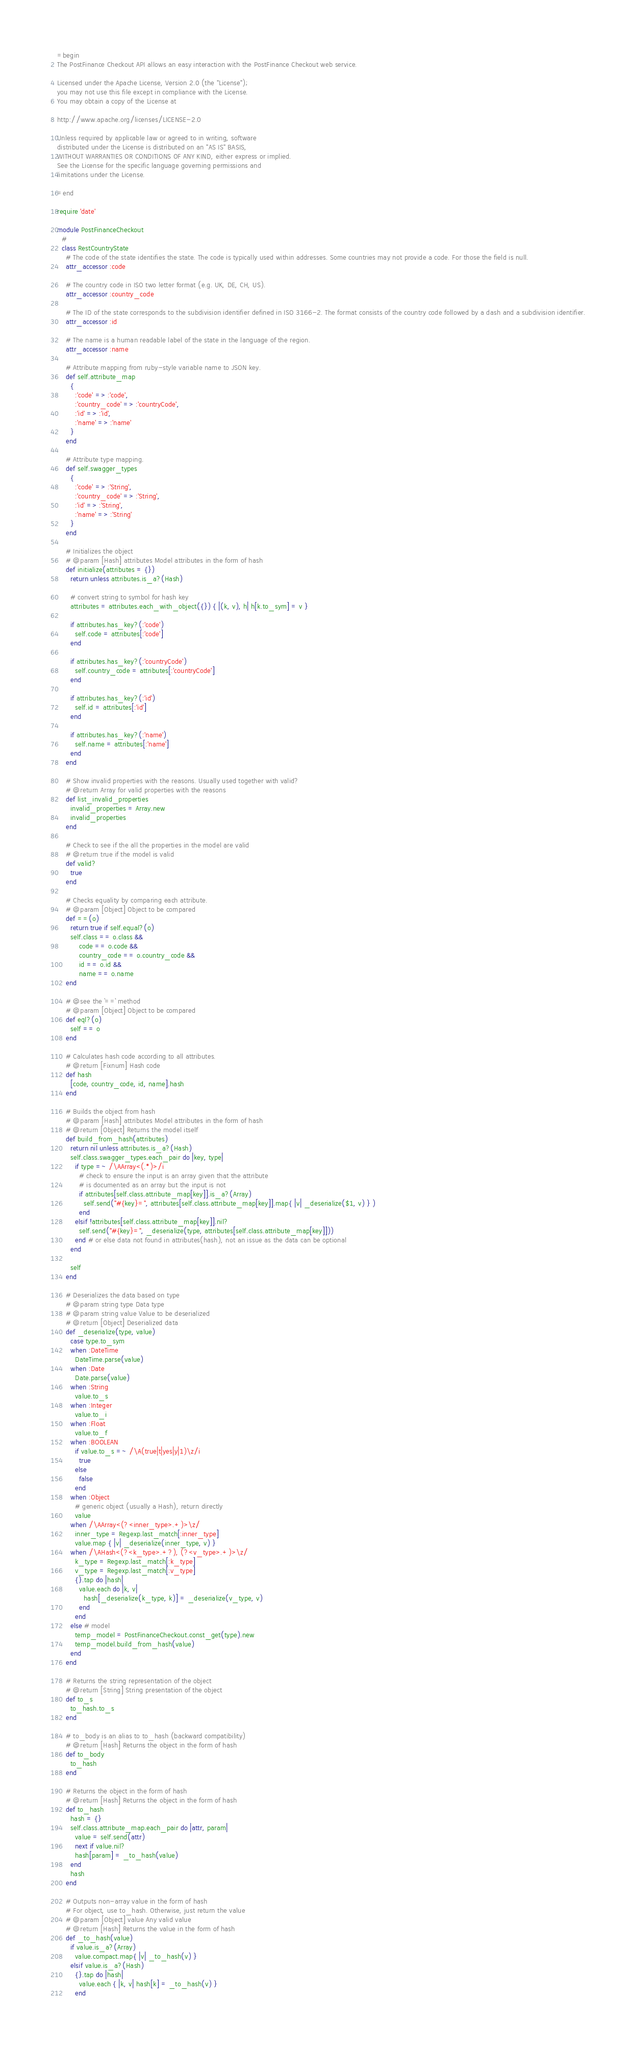<code> <loc_0><loc_0><loc_500><loc_500><_Ruby_>=begin
The PostFinance Checkout API allows an easy interaction with the PostFinance Checkout web service.

Licensed under the Apache License, Version 2.0 (the "License");
you may not use this file except in compliance with the License.
You may obtain a copy of the License at

http://www.apache.org/licenses/LICENSE-2.0

Unless required by applicable law or agreed to in writing, software
distributed under the License is distributed on an "AS IS" BASIS,
WITHOUT WARRANTIES OR CONDITIONS OF ANY KIND, either express or implied.
See the License for the specific language governing permissions and
limitations under the License.

=end

require 'date'

module PostFinanceCheckout
  # 
  class RestCountryState
    # The code of the state identifies the state. The code is typically used within addresses. Some countries may not provide a code. For those the field is null.
    attr_accessor :code

    # The country code in ISO two letter format (e.g. UK, DE, CH, US).
    attr_accessor :country_code

    # The ID of the state corresponds to the subdivision identifier defined in ISO 3166-2. The format consists of the country code followed by a dash and a subdivision identifier.
    attr_accessor :id

    # The name is a human readable label of the state in the language of the region.
    attr_accessor :name

    # Attribute mapping from ruby-style variable name to JSON key.
    def self.attribute_map
      {
        :'code' => :'code',
        :'country_code' => :'countryCode',
        :'id' => :'id',
        :'name' => :'name'
      }
    end

    # Attribute type mapping.
    def self.swagger_types
      {
        :'code' => :'String',
        :'country_code' => :'String',
        :'id' => :'String',
        :'name' => :'String'
      }
    end

    # Initializes the object
    # @param [Hash] attributes Model attributes in the form of hash
    def initialize(attributes = {})
      return unless attributes.is_a?(Hash)

      # convert string to symbol for hash key
      attributes = attributes.each_with_object({}) { |(k, v), h| h[k.to_sym] = v }

      if attributes.has_key?(:'code')
        self.code = attributes[:'code']
      end

      if attributes.has_key?(:'countryCode')
        self.country_code = attributes[:'countryCode']
      end

      if attributes.has_key?(:'id')
        self.id = attributes[:'id']
      end

      if attributes.has_key?(:'name')
        self.name = attributes[:'name']
      end
    end

    # Show invalid properties with the reasons. Usually used together with valid?
    # @return Array for valid properties with the reasons
    def list_invalid_properties
      invalid_properties = Array.new
      invalid_properties
    end

    # Check to see if the all the properties in the model are valid
    # @return true if the model is valid
    def valid?
      true
    end

    # Checks equality by comparing each attribute.
    # @param [Object] Object to be compared
    def ==(o)
      return true if self.equal?(o)
      self.class == o.class &&
          code == o.code &&
          country_code == o.country_code &&
          id == o.id &&
          name == o.name
    end

    # @see the `==` method
    # @param [Object] Object to be compared
    def eql?(o)
      self == o
    end

    # Calculates hash code according to all attributes.
    # @return [Fixnum] Hash code
    def hash
      [code, country_code, id, name].hash
    end

    # Builds the object from hash
    # @param [Hash] attributes Model attributes in the form of hash
    # @return [Object] Returns the model itself
    def build_from_hash(attributes)
      return nil unless attributes.is_a?(Hash)
      self.class.swagger_types.each_pair do |key, type|
        if type =~ /\AArray<(.*)>/i
          # check to ensure the input is an array given that the attribute
          # is documented as an array but the input is not
          if attributes[self.class.attribute_map[key]].is_a?(Array)
            self.send("#{key}=", attributes[self.class.attribute_map[key]].map{ |v| _deserialize($1, v) } )
          end
        elsif !attributes[self.class.attribute_map[key]].nil?
          self.send("#{key}=", _deserialize(type, attributes[self.class.attribute_map[key]]))
        end # or else data not found in attributes(hash), not an issue as the data can be optional
      end

      self
    end

    # Deserializes the data based on type
    # @param string type Data type
    # @param string value Value to be deserialized
    # @return [Object] Deserialized data
    def _deserialize(type, value)
      case type.to_sym
      when :DateTime
        DateTime.parse(value)
      when :Date
        Date.parse(value)
      when :String
        value.to_s
      when :Integer
        value.to_i
      when :Float
        value.to_f
      when :BOOLEAN
        if value.to_s =~ /\A(true|t|yes|y|1)\z/i
          true
        else
          false
        end
      when :Object
        # generic object (usually a Hash), return directly
        value
      when /\AArray<(?<inner_type>.+)>\z/
        inner_type = Regexp.last_match[:inner_type]
        value.map { |v| _deserialize(inner_type, v) }
      when /\AHash<(?<k_type>.+?), (?<v_type>.+)>\z/
        k_type = Regexp.last_match[:k_type]
        v_type = Regexp.last_match[:v_type]
        {}.tap do |hash|
          value.each do |k, v|
            hash[_deserialize(k_type, k)] = _deserialize(v_type, v)
          end
        end
      else # model
        temp_model = PostFinanceCheckout.const_get(type).new
        temp_model.build_from_hash(value)
      end
    end

    # Returns the string representation of the object
    # @return [String] String presentation of the object
    def to_s
      to_hash.to_s
    end

    # to_body is an alias to to_hash (backward compatibility)
    # @return [Hash] Returns the object in the form of hash
    def to_body
      to_hash
    end

    # Returns the object in the form of hash
    # @return [Hash] Returns the object in the form of hash
    def to_hash
      hash = {}
      self.class.attribute_map.each_pair do |attr, param|
        value = self.send(attr)
        next if value.nil?
        hash[param] = _to_hash(value)
      end
      hash
    end

    # Outputs non-array value in the form of hash
    # For object, use to_hash. Otherwise, just return the value
    # @param [Object] value Any valid value
    # @return [Hash] Returns the value in the form of hash
    def _to_hash(value)
      if value.is_a?(Array)
        value.compact.map{ |v| _to_hash(v) }
      elsif value.is_a?(Hash)
        {}.tap do |hash|
          value.each { |k, v| hash[k] = _to_hash(v) }
        end</code> 